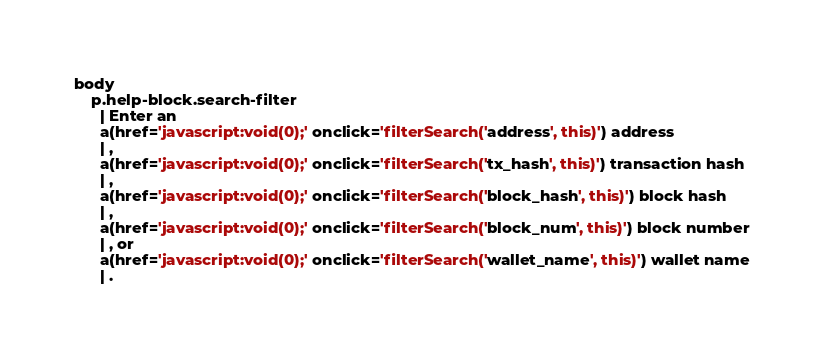<code> <loc_0><loc_0><loc_500><loc_500><_JavaScript_>body
    p.help-block.search-filter
      | Enter an
      a(href='javascript:void(0);' onclick='filterSearch('address', this)') address
      | ,
      a(href='javascript:void(0);' onclick='filterSearch('tx_hash', this)') transaction hash
      | ,
      a(href='javascript:void(0);' onclick='filterSearch('block_hash', this)') block hash
      | ,
      a(href='javascript:void(0);' onclick='filterSearch('block_num', this)') block number
      | , or
      a(href='javascript:void(0);' onclick='filterSearch('wallet_name', this)') wallet name
      | .

</code> 